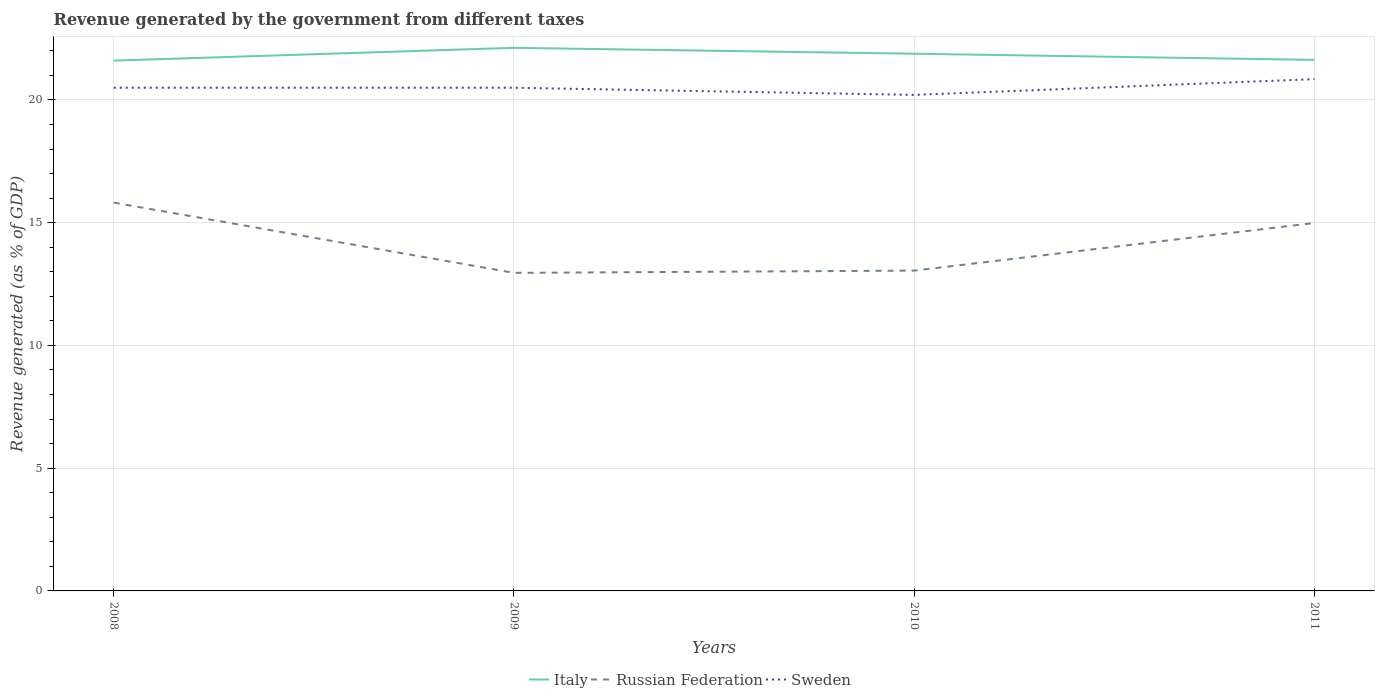How many different coloured lines are there?
Ensure brevity in your answer.  3. Across all years, what is the maximum revenue generated by the government in Sweden?
Offer a very short reply. 20.21. In which year was the revenue generated by the government in Russian Federation maximum?
Provide a short and direct response. 2009. What is the total revenue generated by the government in Russian Federation in the graph?
Make the answer very short. 0.83. What is the difference between the highest and the second highest revenue generated by the government in Italy?
Provide a short and direct response. 0.52. What is the difference between the highest and the lowest revenue generated by the government in Russian Federation?
Make the answer very short. 2. Is the revenue generated by the government in Sweden strictly greater than the revenue generated by the government in Italy over the years?
Ensure brevity in your answer.  Yes. What is the difference between two consecutive major ticks on the Y-axis?
Provide a short and direct response. 5. Does the graph contain any zero values?
Offer a terse response. No. How many legend labels are there?
Provide a short and direct response. 3. How are the legend labels stacked?
Your answer should be compact. Horizontal. What is the title of the graph?
Ensure brevity in your answer.  Revenue generated by the government from different taxes. What is the label or title of the Y-axis?
Provide a succinct answer. Revenue generated (as % of GDP). What is the Revenue generated (as % of GDP) in Italy in 2008?
Give a very brief answer. 21.6. What is the Revenue generated (as % of GDP) in Russian Federation in 2008?
Your answer should be compact. 15.82. What is the Revenue generated (as % of GDP) of Sweden in 2008?
Your answer should be compact. 20.5. What is the Revenue generated (as % of GDP) in Italy in 2009?
Your answer should be compact. 22.12. What is the Revenue generated (as % of GDP) in Russian Federation in 2009?
Give a very brief answer. 12.96. What is the Revenue generated (as % of GDP) of Sweden in 2009?
Ensure brevity in your answer.  20.5. What is the Revenue generated (as % of GDP) of Italy in 2010?
Give a very brief answer. 21.88. What is the Revenue generated (as % of GDP) of Russian Federation in 2010?
Provide a succinct answer. 13.05. What is the Revenue generated (as % of GDP) in Sweden in 2010?
Your response must be concise. 20.21. What is the Revenue generated (as % of GDP) in Italy in 2011?
Your answer should be very brief. 21.63. What is the Revenue generated (as % of GDP) in Russian Federation in 2011?
Make the answer very short. 14.99. What is the Revenue generated (as % of GDP) in Sweden in 2011?
Ensure brevity in your answer.  20.85. Across all years, what is the maximum Revenue generated (as % of GDP) in Italy?
Provide a short and direct response. 22.12. Across all years, what is the maximum Revenue generated (as % of GDP) in Russian Federation?
Your answer should be very brief. 15.82. Across all years, what is the maximum Revenue generated (as % of GDP) in Sweden?
Provide a succinct answer. 20.85. Across all years, what is the minimum Revenue generated (as % of GDP) of Italy?
Your answer should be very brief. 21.6. Across all years, what is the minimum Revenue generated (as % of GDP) of Russian Federation?
Keep it short and to the point. 12.96. Across all years, what is the minimum Revenue generated (as % of GDP) of Sweden?
Give a very brief answer. 20.21. What is the total Revenue generated (as % of GDP) in Italy in the graph?
Ensure brevity in your answer.  87.24. What is the total Revenue generated (as % of GDP) in Russian Federation in the graph?
Provide a succinct answer. 56.81. What is the total Revenue generated (as % of GDP) in Sweden in the graph?
Make the answer very short. 82.05. What is the difference between the Revenue generated (as % of GDP) of Italy in 2008 and that in 2009?
Provide a short and direct response. -0.52. What is the difference between the Revenue generated (as % of GDP) in Russian Federation in 2008 and that in 2009?
Keep it short and to the point. 2.86. What is the difference between the Revenue generated (as % of GDP) of Sweden in 2008 and that in 2009?
Your answer should be compact. 0. What is the difference between the Revenue generated (as % of GDP) in Italy in 2008 and that in 2010?
Provide a succinct answer. -0.28. What is the difference between the Revenue generated (as % of GDP) of Russian Federation in 2008 and that in 2010?
Your response must be concise. 2.77. What is the difference between the Revenue generated (as % of GDP) of Sweden in 2008 and that in 2010?
Provide a short and direct response. 0.29. What is the difference between the Revenue generated (as % of GDP) of Italy in 2008 and that in 2011?
Provide a short and direct response. -0.03. What is the difference between the Revenue generated (as % of GDP) of Russian Federation in 2008 and that in 2011?
Your answer should be very brief. 0.83. What is the difference between the Revenue generated (as % of GDP) in Sweden in 2008 and that in 2011?
Provide a succinct answer. -0.35. What is the difference between the Revenue generated (as % of GDP) of Italy in 2009 and that in 2010?
Ensure brevity in your answer.  0.24. What is the difference between the Revenue generated (as % of GDP) of Russian Federation in 2009 and that in 2010?
Your answer should be compact. -0.09. What is the difference between the Revenue generated (as % of GDP) of Sweden in 2009 and that in 2010?
Make the answer very short. 0.29. What is the difference between the Revenue generated (as % of GDP) of Italy in 2009 and that in 2011?
Give a very brief answer. 0.49. What is the difference between the Revenue generated (as % of GDP) of Russian Federation in 2009 and that in 2011?
Offer a very short reply. -2.03. What is the difference between the Revenue generated (as % of GDP) of Sweden in 2009 and that in 2011?
Offer a very short reply. -0.35. What is the difference between the Revenue generated (as % of GDP) in Italy in 2010 and that in 2011?
Your answer should be compact. 0.25. What is the difference between the Revenue generated (as % of GDP) of Russian Federation in 2010 and that in 2011?
Offer a terse response. -1.94. What is the difference between the Revenue generated (as % of GDP) of Sweden in 2010 and that in 2011?
Your response must be concise. -0.64. What is the difference between the Revenue generated (as % of GDP) of Italy in 2008 and the Revenue generated (as % of GDP) of Russian Federation in 2009?
Keep it short and to the point. 8.65. What is the difference between the Revenue generated (as % of GDP) in Italy in 2008 and the Revenue generated (as % of GDP) in Sweden in 2009?
Your response must be concise. 1.1. What is the difference between the Revenue generated (as % of GDP) of Russian Federation in 2008 and the Revenue generated (as % of GDP) of Sweden in 2009?
Offer a terse response. -4.68. What is the difference between the Revenue generated (as % of GDP) of Italy in 2008 and the Revenue generated (as % of GDP) of Russian Federation in 2010?
Provide a short and direct response. 8.55. What is the difference between the Revenue generated (as % of GDP) of Italy in 2008 and the Revenue generated (as % of GDP) of Sweden in 2010?
Your response must be concise. 1.4. What is the difference between the Revenue generated (as % of GDP) in Russian Federation in 2008 and the Revenue generated (as % of GDP) in Sweden in 2010?
Provide a succinct answer. -4.39. What is the difference between the Revenue generated (as % of GDP) in Italy in 2008 and the Revenue generated (as % of GDP) in Russian Federation in 2011?
Offer a terse response. 6.61. What is the difference between the Revenue generated (as % of GDP) of Italy in 2008 and the Revenue generated (as % of GDP) of Sweden in 2011?
Offer a very short reply. 0.75. What is the difference between the Revenue generated (as % of GDP) in Russian Federation in 2008 and the Revenue generated (as % of GDP) in Sweden in 2011?
Offer a very short reply. -5.03. What is the difference between the Revenue generated (as % of GDP) in Italy in 2009 and the Revenue generated (as % of GDP) in Russian Federation in 2010?
Make the answer very short. 9.07. What is the difference between the Revenue generated (as % of GDP) in Italy in 2009 and the Revenue generated (as % of GDP) in Sweden in 2010?
Offer a very short reply. 1.92. What is the difference between the Revenue generated (as % of GDP) of Russian Federation in 2009 and the Revenue generated (as % of GDP) of Sweden in 2010?
Your answer should be very brief. -7.25. What is the difference between the Revenue generated (as % of GDP) of Italy in 2009 and the Revenue generated (as % of GDP) of Russian Federation in 2011?
Ensure brevity in your answer.  7.14. What is the difference between the Revenue generated (as % of GDP) of Italy in 2009 and the Revenue generated (as % of GDP) of Sweden in 2011?
Your answer should be compact. 1.28. What is the difference between the Revenue generated (as % of GDP) in Russian Federation in 2009 and the Revenue generated (as % of GDP) in Sweden in 2011?
Ensure brevity in your answer.  -7.89. What is the difference between the Revenue generated (as % of GDP) in Italy in 2010 and the Revenue generated (as % of GDP) in Russian Federation in 2011?
Ensure brevity in your answer.  6.9. What is the difference between the Revenue generated (as % of GDP) in Italy in 2010 and the Revenue generated (as % of GDP) in Sweden in 2011?
Offer a terse response. 1.04. What is the difference between the Revenue generated (as % of GDP) in Russian Federation in 2010 and the Revenue generated (as % of GDP) in Sweden in 2011?
Your answer should be compact. -7.8. What is the average Revenue generated (as % of GDP) in Italy per year?
Offer a terse response. 21.81. What is the average Revenue generated (as % of GDP) in Russian Federation per year?
Provide a short and direct response. 14.2. What is the average Revenue generated (as % of GDP) in Sweden per year?
Your answer should be very brief. 20.51. In the year 2008, what is the difference between the Revenue generated (as % of GDP) of Italy and Revenue generated (as % of GDP) of Russian Federation?
Give a very brief answer. 5.78. In the year 2008, what is the difference between the Revenue generated (as % of GDP) of Italy and Revenue generated (as % of GDP) of Sweden?
Your answer should be compact. 1.1. In the year 2008, what is the difference between the Revenue generated (as % of GDP) of Russian Federation and Revenue generated (as % of GDP) of Sweden?
Your answer should be very brief. -4.68. In the year 2009, what is the difference between the Revenue generated (as % of GDP) of Italy and Revenue generated (as % of GDP) of Russian Federation?
Provide a short and direct response. 9.17. In the year 2009, what is the difference between the Revenue generated (as % of GDP) of Italy and Revenue generated (as % of GDP) of Sweden?
Provide a succinct answer. 1.63. In the year 2009, what is the difference between the Revenue generated (as % of GDP) in Russian Federation and Revenue generated (as % of GDP) in Sweden?
Provide a short and direct response. -7.54. In the year 2010, what is the difference between the Revenue generated (as % of GDP) of Italy and Revenue generated (as % of GDP) of Russian Federation?
Offer a terse response. 8.84. In the year 2010, what is the difference between the Revenue generated (as % of GDP) in Italy and Revenue generated (as % of GDP) in Sweden?
Provide a short and direct response. 1.68. In the year 2010, what is the difference between the Revenue generated (as % of GDP) in Russian Federation and Revenue generated (as % of GDP) in Sweden?
Provide a succinct answer. -7.16. In the year 2011, what is the difference between the Revenue generated (as % of GDP) in Italy and Revenue generated (as % of GDP) in Russian Federation?
Give a very brief answer. 6.64. In the year 2011, what is the difference between the Revenue generated (as % of GDP) in Italy and Revenue generated (as % of GDP) in Sweden?
Your answer should be compact. 0.78. In the year 2011, what is the difference between the Revenue generated (as % of GDP) in Russian Federation and Revenue generated (as % of GDP) in Sweden?
Ensure brevity in your answer.  -5.86. What is the ratio of the Revenue generated (as % of GDP) of Italy in 2008 to that in 2009?
Ensure brevity in your answer.  0.98. What is the ratio of the Revenue generated (as % of GDP) of Russian Federation in 2008 to that in 2009?
Your answer should be compact. 1.22. What is the ratio of the Revenue generated (as % of GDP) in Sweden in 2008 to that in 2009?
Offer a very short reply. 1. What is the ratio of the Revenue generated (as % of GDP) of Italy in 2008 to that in 2010?
Provide a succinct answer. 0.99. What is the ratio of the Revenue generated (as % of GDP) in Russian Federation in 2008 to that in 2010?
Provide a succinct answer. 1.21. What is the ratio of the Revenue generated (as % of GDP) of Sweden in 2008 to that in 2010?
Offer a terse response. 1.01. What is the ratio of the Revenue generated (as % of GDP) in Italy in 2008 to that in 2011?
Your response must be concise. 1. What is the ratio of the Revenue generated (as % of GDP) in Russian Federation in 2008 to that in 2011?
Your answer should be very brief. 1.06. What is the ratio of the Revenue generated (as % of GDP) in Sweden in 2008 to that in 2011?
Ensure brevity in your answer.  0.98. What is the ratio of the Revenue generated (as % of GDP) of Sweden in 2009 to that in 2010?
Give a very brief answer. 1.01. What is the ratio of the Revenue generated (as % of GDP) in Italy in 2009 to that in 2011?
Your answer should be very brief. 1.02. What is the ratio of the Revenue generated (as % of GDP) of Russian Federation in 2009 to that in 2011?
Provide a succinct answer. 0.86. What is the ratio of the Revenue generated (as % of GDP) in Sweden in 2009 to that in 2011?
Offer a very short reply. 0.98. What is the ratio of the Revenue generated (as % of GDP) in Italy in 2010 to that in 2011?
Your answer should be very brief. 1.01. What is the ratio of the Revenue generated (as % of GDP) of Russian Federation in 2010 to that in 2011?
Provide a short and direct response. 0.87. What is the ratio of the Revenue generated (as % of GDP) in Sweden in 2010 to that in 2011?
Your answer should be compact. 0.97. What is the difference between the highest and the second highest Revenue generated (as % of GDP) in Italy?
Ensure brevity in your answer.  0.24. What is the difference between the highest and the second highest Revenue generated (as % of GDP) of Russian Federation?
Your answer should be compact. 0.83. What is the difference between the highest and the second highest Revenue generated (as % of GDP) of Sweden?
Your answer should be compact. 0.35. What is the difference between the highest and the lowest Revenue generated (as % of GDP) in Italy?
Ensure brevity in your answer.  0.52. What is the difference between the highest and the lowest Revenue generated (as % of GDP) in Russian Federation?
Provide a short and direct response. 2.86. What is the difference between the highest and the lowest Revenue generated (as % of GDP) in Sweden?
Give a very brief answer. 0.64. 